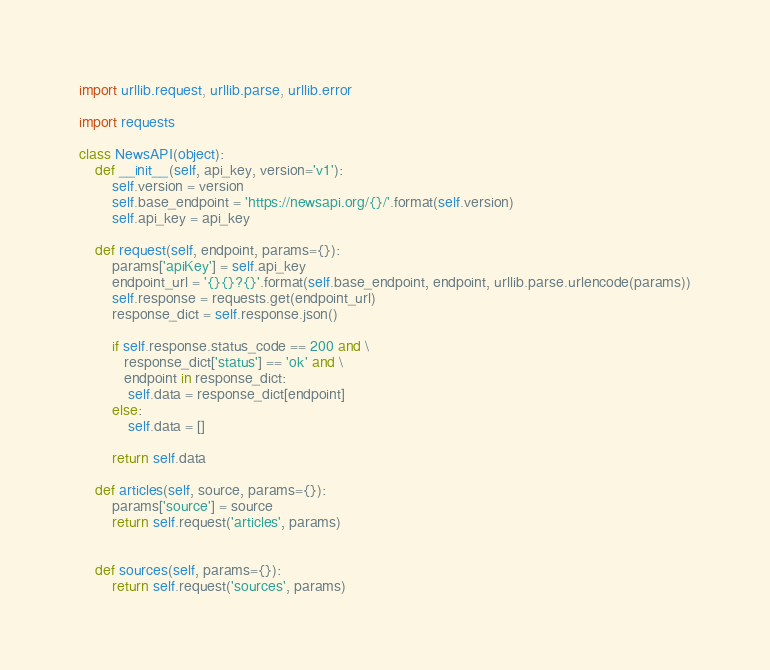Convert code to text. <code><loc_0><loc_0><loc_500><loc_500><_Python_>import urllib.request, urllib.parse, urllib.error

import requests

class NewsAPI(object):
    def __init__(self, api_key, version='v1'):
        self.version = version
        self.base_endpoint = 'https://newsapi.org/{}/'.format(self.version)
        self.api_key = api_key

    def request(self, endpoint, params={}):
        params['apiKey'] = self.api_key
        endpoint_url = '{}{}?{}'.format(self.base_endpoint, endpoint, urllib.parse.urlencode(params))
        self.response = requests.get(endpoint_url)
        response_dict = self.response.json()

        if self.response.status_code == 200 and \
           response_dict['status'] == 'ok' and \
           endpoint in response_dict:
            self.data = response_dict[endpoint]
        else:
            self.data = []

        return self.data

    def articles(self, source, params={}):
        params['source'] = source
        return self.request('articles', params)


    def sources(self, params={}):
        return self.request('sources', params)

</code> 